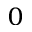Convert formula to latex. <formula><loc_0><loc_0><loc_500><loc_500>_ { 0 }</formula> 